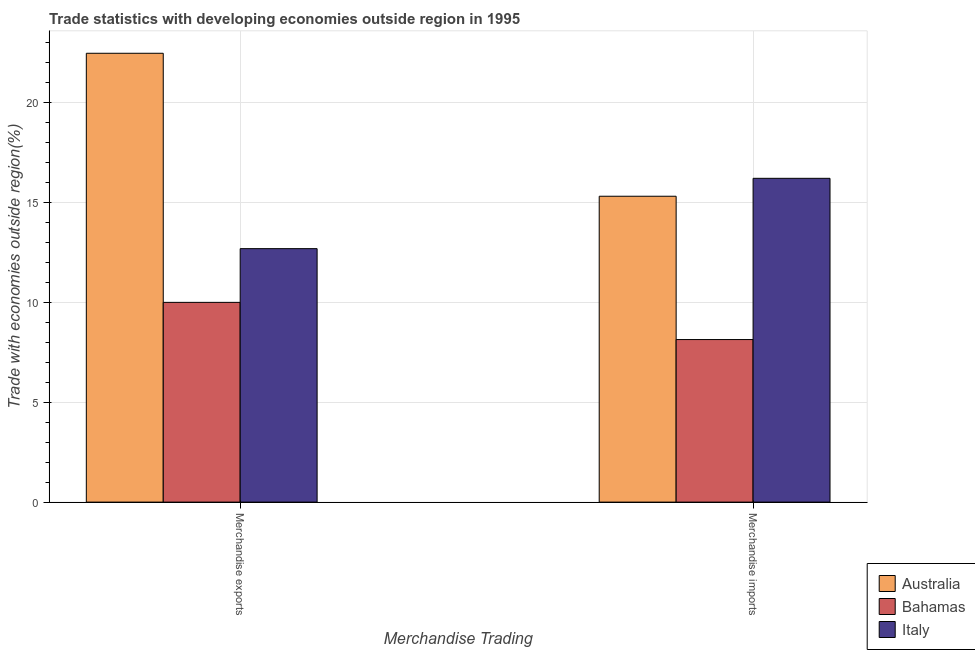How many bars are there on the 1st tick from the left?
Provide a succinct answer. 3. How many bars are there on the 2nd tick from the right?
Provide a short and direct response. 3. What is the label of the 2nd group of bars from the left?
Your response must be concise. Merchandise imports. What is the merchandise imports in Australia?
Make the answer very short. 15.3. Across all countries, what is the maximum merchandise exports?
Make the answer very short. 22.45. Across all countries, what is the minimum merchandise exports?
Offer a terse response. 9.99. In which country was the merchandise exports maximum?
Provide a short and direct response. Australia. In which country was the merchandise exports minimum?
Your answer should be compact. Bahamas. What is the total merchandise imports in the graph?
Give a very brief answer. 39.62. What is the difference between the merchandise exports in Bahamas and that in Australia?
Keep it short and to the point. -12.46. What is the difference between the merchandise imports in Italy and the merchandise exports in Bahamas?
Give a very brief answer. 6.2. What is the average merchandise exports per country?
Make the answer very short. 15.04. What is the difference between the merchandise exports and merchandise imports in Australia?
Provide a succinct answer. 7.15. What is the ratio of the merchandise exports in Bahamas to that in Australia?
Offer a terse response. 0.45. Is the merchandise exports in Bahamas less than that in Italy?
Ensure brevity in your answer.  Yes. In how many countries, is the merchandise imports greater than the average merchandise imports taken over all countries?
Keep it short and to the point. 2. What does the 3rd bar from the left in Merchandise imports represents?
Your answer should be very brief. Italy. What does the 3rd bar from the right in Merchandise imports represents?
Offer a terse response. Australia. How many bars are there?
Give a very brief answer. 6. What is the difference between two consecutive major ticks on the Y-axis?
Offer a terse response. 5. Does the graph contain any zero values?
Provide a short and direct response. No. Where does the legend appear in the graph?
Ensure brevity in your answer.  Bottom right. How are the legend labels stacked?
Your response must be concise. Vertical. What is the title of the graph?
Keep it short and to the point. Trade statistics with developing economies outside region in 1995. Does "Costa Rica" appear as one of the legend labels in the graph?
Give a very brief answer. No. What is the label or title of the X-axis?
Offer a terse response. Merchandise Trading. What is the label or title of the Y-axis?
Your answer should be compact. Trade with economies outside region(%). What is the Trade with economies outside region(%) of Australia in Merchandise exports?
Give a very brief answer. 22.45. What is the Trade with economies outside region(%) of Bahamas in Merchandise exports?
Give a very brief answer. 9.99. What is the Trade with economies outside region(%) in Italy in Merchandise exports?
Give a very brief answer. 12.68. What is the Trade with economies outside region(%) in Australia in Merchandise imports?
Your answer should be compact. 15.3. What is the Trade with economies outside region(%) of Bahamas in Merchandise imports?
Ensure brevity in your answer.  8.13. What is the Trade with economies outside region(%) in Italy in Merchandise imports?
Your response must be concise. 16.19. Across all Merchandise Trading, what is the maximum Trade with economies outside region(%) in Australia?
Offer a very short reply. 22.45. Across all Merchandise Trading, what is the maximum Trade with economies outside region(%) of Bahamas?
Make the answer very short. 9.99. Across all Merchandise Trading, what is the maximum Trade with economies outside region(%) in Italy?
Keep it short and to the point. 16.19. Across all Merchandise Trading, what is the minimum Trade with economies outside region(%) in Australia?
Offer a very short reply. 15.3. Across all Merchandise Trading, what is the minimum Trade with economies outside region(%) in Bahamas?
Your response must be concise. 8.13. Across all Merchandise Trading, what is the minimum Trade with economies outside region(%) in Italy?
Offer a terse response. 12.68. What is the total Trade with economies outside region(%) of Australia in the graph?
Your response must be concise. 37.75. What is the total Trade with economies outside region(%) in Bahamas in the graph?
Offer a very short reply. 18.12. What is the total Trade with economies outside region(%) in Italy in the graph?
Provide a succinct answer. 28.87. What is the difference between the Trade with economies outside region(%) in Australia in Merchandise exports and that in Merchandise imports?
Keep it short and to the point. 7.15. What is the difference between the Trade with economies outside region(%) in Bahamas in Merchandise exports and that in Merchandise imports?
Provide a succinct answer. 1.86. What is the difference between the Trade with economies outside region(%) in Italy in Merchandise exports and that in Merchandise imports?
Provide a succinct answer. -3.52. What is the difference between the Trade with economies outside region(%) of Australia in Merchandise exports and the Trade with economies outside region(%) of Bahamas in Merchandise imports?
Give a very brief answer. 14.32. What is the difference between the Trade with economies outside region(%) of Australia in Merchandise exports and the Trade with economies outside region(%) of Italy in Merchandise imports?
Make the answer very short. 6.25. What is the difference between the Trade with economies outside region(%) of Bahamas in Merchandise exports and the Trade with economies outside region(%) of Italy in Merchandise imports?
Give a very brief answer. -6.2. What is the average Trade with economies outside region(%) in Australia per Merchandise Trading?
Provide a short and direct response. 18.87. What is the average Trade with economies outside region(%) of Bahamas per Merchandise Trading?
Provide a succinct answer. 9.06. What is the average Trade with economies outside region(%) in Italy per Merchandise Trading?
Give a very brief answer. 14.44. What is the difference between the Trade with economies outside region(%) of Australia and Trade with economies outside region(%) of Bahamas in Merchandise exports?
Offer a very short reply. 12.46. What is the difference between the Trade with economies outside region(%) in Australia and Trade with economies outside region(%) in Italy in Merchandise exports?
Offer a very short reply. 9.77. What is the difference between the Trade with economies outside region(%) in Bahamas and Trade with economies outside region(%) in Italy in Merchandise exports?
Ensure brevity in your answer.  -2.69. What is the difference between the Trade with economies outside region(%) in Australia and Trade with economies outside region(%) in Bahamas in Merchandise imports?
Give a very brief answer. 7.17. What is the difference between the Trade with economies outside region(%) in Australia and Trade with economies outside region(%) in Italy in Merchandise imports?
Ensure brevity in your answer.  -0.9. What is the difference between the Trade with economies outside region(%) in Bahamas and Trade with economies outside region(%) in Italy in Merchandise imports?
Give a very brief answer. -8.06. What is the ratio of the Trade with economies outside region(%) of Australia in Merchandise exports to that in Merchandise imports?
Make the answer very short. 1.47. What is the ratio of the Trade with economies outside region(%) in Bahamas in Merchandise exports to that in Merchandise imports?
Make the answer very short. 1.23. What is the ratio of the Trade with economies outside region(%) of Italy in Merchandise exports to that in Merchandise imports?
Make the answer very short. 0.78. What is the difference between the highest and the second highest Trade with economies outside region(%) of Australia?
Your answer should be very brief. 7.15. What is the difference between the highest and the second highest Trade with economies outside region(%) of Bahamas?
Offer a very short reply. 1.86. What is the difference between the highest and the second highest Trade with economies outside region(%) in Italy?
Ensure brevity in your answer.  3.52. What is the difference between the highest and the lowest Trade with economies outside region(%) in Australia?
Your response must be concise. 7.15. What is the difference between the highest and the lowest Trade with economies outside region(%) in Bahamas?
Make the answer very short. 1.86. What is the difference between the highest and the lowest Trade with economies outside region(%) in Italy?
Make the answer very short. 3.52. 